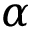<formula> <loc_0><loc_0><loc_500><loc_500>\alpha</formula> 